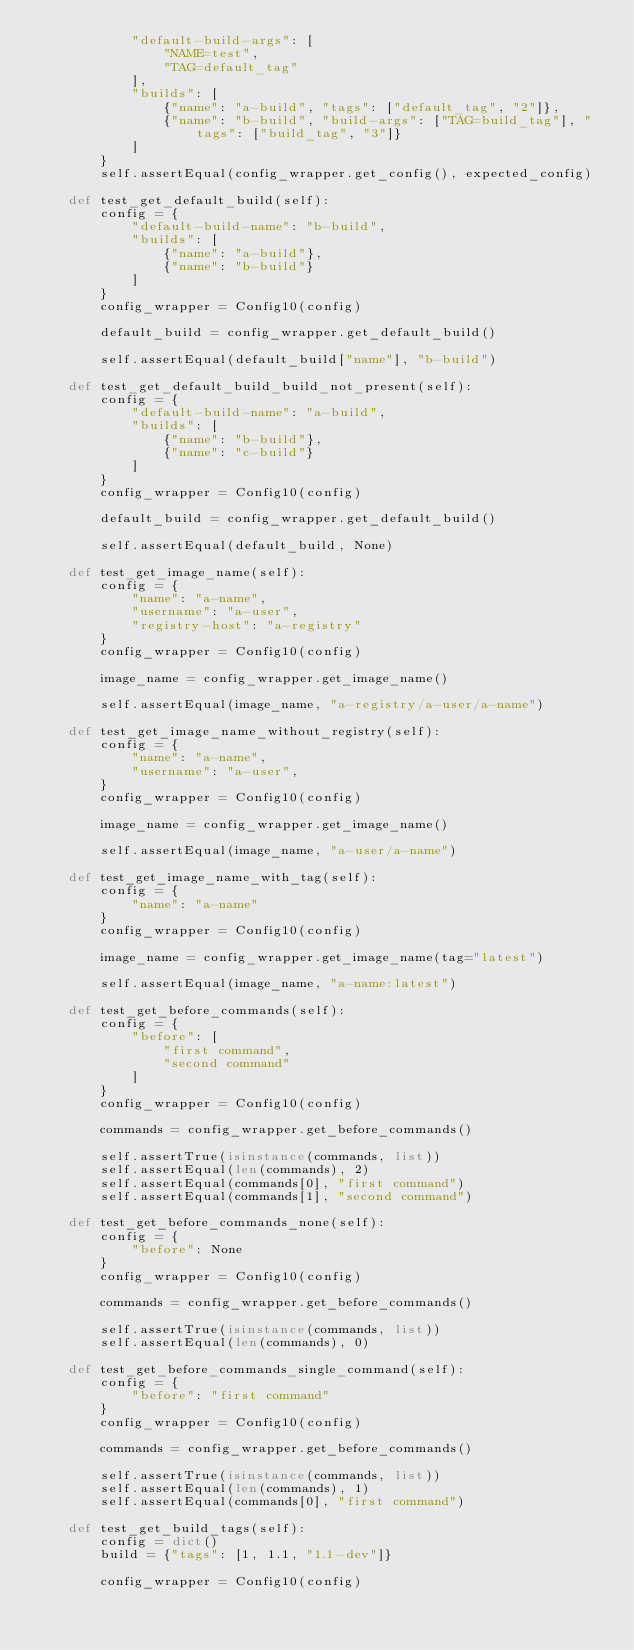Convert code to text. <code><loc_0><loc_0><loc_500><loc_500><_Python_>            "default-build-args": [
                "NAME=test",
                "TAG=default_tag"
            ],
            "builds": [
                {"name": "a-build", "tags": ["default_tag", "2"]},
                {"name": "b-build", "build-args": ["TAG=build_tag"], "tags": ["build_tag", "3"]}
            ]
        }
        self.assertEqual(config_wrapper.get_config(), expected_config)

    def test_get_default_build(self):
        config = {
            "default-build-name": "b-build",
            "builds": [
                {"name": "a-build"},
                {"name": "b-build"}
            ]
        }
        config_wrapper = Config10(config)

        default_build = config_wrapper.get_default_build()

        self.assertEqual(default_build["name"], "b-build")

    def test_get_default_build_build_not_present(self):
        config = {
            "default-build-name": "a-build",
            "builds": [
                {"name": "b-build"},
                {"name": "c-build"}
            ]
        }
        config_wrapper = Config10(config)

        default_build = config_wrapper.get_default_build()

        self.assertEqual(default_build, None)

    def test_get_image_name(self):
        config = {
            "name": "a-name",
            "username": "a-user",
            "registry-host": "a-registry"
        }
        config_wrapper = Config10(config)

        image_name = config_wrapper.get_image_name()

        self.assertEqual(image_name, "a-registry/a-user/a-name")

    def test_get_image_name_without_registry(self):
        config = {
            "name": "a-name",
            "username": "a-user",
        }
        config_wrapper = Config10(config)

        image_name = config_wrapper.get_image_name()

        self.assertEqual(image_name, "a-user/a-name")

    def test_get_image_name_with_tag(self):
        config = {
            "name": "a-name"
        }
        config_wrapper = Config10(config)

        image_name = config_wrapper.get_image_name(tag="latest")

        self.assertEqual(image_name, "a-name:latest")

    def test_get_before_commands(self):
        config = {
            "before": [
                "first command",
                "second command"
            ]
        }
        config_wrapper = Config10(config)

        commands = config_wrapper.get_before_commands()

        self.assertTrue(isinstance(commands, list))
        self.assertEqual(len(commands), 2)
        self.assertEqual(commands[0], "first command")
        self.assertEqual(commands[1], "second command")

    def test_get_before_commands_none(self):
        config = {
            "before": None
        }
        config_wrapper = Config10(config)

        commands = config_wrapper.get_before_commands()

        self.assertTrue(isinstance(commands, list))
        self.assertEqual(len(commands), 0)

    def test_get_before_commands_single_command(self):
        config = {
            "before": "first command"
        }
        config_wrapper = Config10(config)

        commands = config_wrapper.get_before_commands()

        self.assertTrue(isinstance(commands, list))
        self.assertEqual(len(commands), 1)
        self.assertEqual(commands[0], "first command")

    def test_get_build_tags(self):
        config = dict()
        build = {"tags": [1, 1.1, "1.1-dev"]}

        config_wrapper = Config10(config)
</code> 